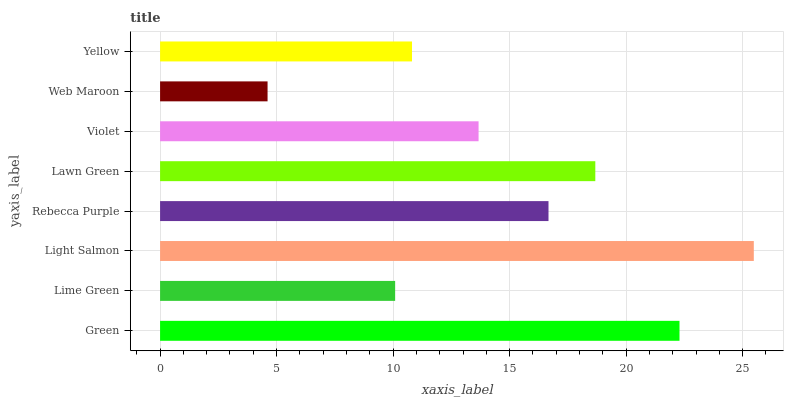Is Web Maroon the minimum?
Answer yes or no. Yes. Is Light Salmon the maximum?
Answer yes or no. Yes. Is Lime Green the minimum?
Answer yes or no. No. Is Lime Green the maximum?
Answer yes or no. No. Is Green greater than Lime Green?
Answer yes or no. Yes. Is Lime Green less than Green?
Answer yes or no. Yes. Is Lime Green greater than Green?
Answer yes or no. No. Is Green less than Lime Green?
Answer yes or no. No. Is Rebecca Purple the high median?
Answer yes or no. Yes. Is Violet the low median?
Answer yes or no. Yes. Is Lime Green the high median?
Answer yes or no. No. Is Lime Green the low median?
Answer yes or no. No. 